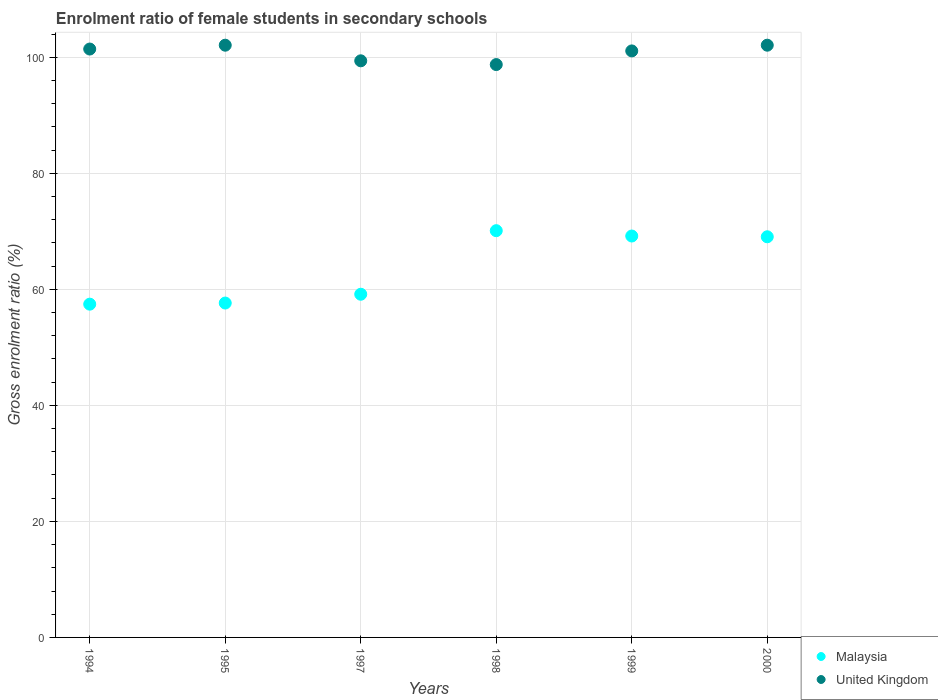What is the enrolment ratio of female students in secondary schools in United Kingdom in 1999?
Offer a terse response. 101.09. Across all years, what is the maximum enrolment ratio of female students in secondary schools in United Kingdom?
Make the answer very short. 102.07. Across all years, what is the minimum enrolment ratio of female students in secondary schools in Malaysia?
Provide a short and direct response. 57.44. In which year was the enrolment ratio of female students in secondary schools in United Kingdom maximum?
Provide a short and direct response. 2000. What is the total enrolment ratio of female students in secondary schools in United Kingdom in the graph?
Give a very brief answer. 604.77. What is the difference between the enrolment ratio of female students in secondary schools in Malaysia in 1998 and that in 1999?
Keep it short and to the point. 0.92. What is the difference between the enrolment ratio of female students in secondary schools in United Kingdom in 1994 and the enrolment ratio of female students in secondary schools in Malaysia in 1997?
Your answer should be very brief. 42.26. What is the average enrolment ratio of female students in secondary schools in Malaysia per year?
Offer a terse response. 63.76. In the year 2000, what is the difference between the enrolment ratio of female students in secondary schools in United Kingdom and enrolment ratio of female students in secondary schools in Malaysia?
Keep it short and to the point. 33.02. What is the ratio of the enrolment ratio of female students in secondary schools in United Kingdom in 1997 to that in 1998?
Provide a succinct answer. 1.01. Is the enrolment ratio of female students in secondary schools in Malaysia in 1997 less than that in 2000?
Your answer should be compact. Yes. What is the difference between the highest and the second highest enrolment ratio of female students in secondary schools in Malaysia?
Make the answer very short. 0.92. What is the difference between the highest and the lowest enrolment ratio of female students in secondary schools in United Kingdom?
Provide a succinct answer. 3.34. In how many years, is the enrolment ratio of female students in secondary schools in Malaysia greater than the average enrolment ratio of female students in secondary schools in Malaysia taken over all years?
Offer a terse response. 3. Is the sum of the enrolment ratio of female students in secondary schools in Malaysia in 1994 and 1997 greater than the maximum enrolment ratio of female students in secondary schools in United Kingdom across all years?
Your answer should be very brief. Yes. Does the enrolment ratio of female students in secondary schools in Malaysia monotonically increase over the years?
Your answer should be compact. No. Is the enrolment ratio of female students in secondary schools in United Kingdom strictly greater than the enrolment ratio of female students in secondary schools in Malaysia over the years?
Give a very brief answer. Yes. Is the enrolment ratio of female students in secondary schools in Malaysia strictly less than the enrolment ratio of female students in secondary schools in United Kingdom over the years?
Your response must be concise. Yes. How many dotlines are there?
Offer a very short reply. 2. What is the difference between two consecutive major ticks on the Y-axis?
Keep it short and to the point. 20. Does the graph contain any zero values?
Keep it short and to the point. No. Does the graph contain grids?
Your answer should be compact. Yes. Where does the legend appear in the graph?
Your answer should be compact. Bottom right. How many legend labels are there?
Keep it short and to the point. 2. How are the legend labels stacked?
Keep it short and to the point. Vertical. What is the title of the graph?
Ensure brevity in your answer.  Enrolment ratio of female students in secondary schools. What is the label or title of the X-axis?
Your answer should be very brief. Years. What is the label or title of the Y-axis?
Your response must be concise. Gross enrolment ratio (%). What is the Gross enrolment ratio (%) in Malaysia in 1994?
Keep it short and to the point. 57.44. What is the Gross enrolment ratio (%) in United Kingdom in 1994?
Offer a very short reply. 101.41. What is the Gross enrolment ratio (%) in Malaysia in 1995?
Your answer should be compact. 57.63. What is the Gross enrolment ratio (%) in United Kingdom in 1995?
Give a very brief answer. 102.07. What is the Gross enrolment ratio (%) in Malaysia in 1997?
Your response must be concise. 59.15. What is the Gross enrolment ratio (%) of United Kingdom in 1997?
Offer a very short reply. 99.38. What is the Gross enrolment ratio (%) of Malaysia in 1998?
Your answer should be compact. 70.1. What is the Gross enrolment ratio (%) in United Kingdom in 1998?
Offer a very short reply. 98.74. What is the Gross enrolment ratio (%) in Malaysia in 1999?
Offer a terse response. 69.19. What is the Gross enrolment ratio (%) in United Kingdom in 1999?
Provide a short and direct response. 101.09. What is the Gross enrolment ratio (%) in Malaysia in 2000?
Keep it short and to the point. 69.05. What is the Gross enrolment ratio (%) of United Kingdom in 2000?
Ensure brevity in your answer.  102.07. Across all years, what is the maximum Gross enrolment ratio (%) of Malaysia?
Offer a very short reply. 70.1. Across all years, what is the maximum Gross enrolment ratio (%) in United Kingdom?
Your response must be concise. 102.07. Across all years, what is the minimum Gross enrolment ratio (%) of Malaysia?
Give a very brief answer. 57.44. Across all years, what is the minimum Gross enrolment ratio (%) of United Kingdom?
Your response must be concise. 98.74. What is the total Gross enrolment ratio (%) in Malaysia in the graph?
Give a very brief answer. 382.57. What is the total Gross enrolment ratio (%) in United Kingdom in the graph?
Give a very brief answer. 604.77. What is the difference between the Gross enrolment ratio (%) of Malaysia in 1994 and that in 1995?
Your answer should be very brief. -0.19. What is the difference between the Gross enrolment ratio (%) of United Kingdom in 1994 and that in 1995?
Your answer should be very brief. -0.66. What is the difference between the Gross enrolment ratio (%) of Malaysia in 1994 and that in 1997?
Give a very brief answer. -1.71. What is the difference between the Gross enrolment ratio (%) of United Kingdom in 1994 and that in 1997?
Offer a terse response. 2.03. What is the difference between the Gross enrolment ratio (%) in Malaysia in 1994 and that in 1998?
Give a very brief answer. -12.67. What is the difference between the Gross enrolment ratio (%) in United Kingdom in 1994 and that in 1998?
Your answer should be compact. 2.68. What is the difference between the Gross enrolment ratio (%) of Malaysia in 1994 and that in 1999?
Your response must be concise. -11.75. What is the difference between the Gross enrolment ratio (%) in United Kingdom in 1994 and that in 1999?
Your answer should be compact. 0.32. What is the difference between the Gross enrolment ratio (%) of Malaysia in 1994 and that in 2000?
Your answer should be very brief. -11.61. What is the difference between the Gross enrolment ratio (%) in United Kingdom in 1994 and that in 2000?
Provide a short and direct response. -0.66. What is the difference between the Gross enrolment ratio (%) in Malaysia in 1995 and that in 1997?
Provide a short and direct response. -1.52. What is the difference between the Gross enrolment ratio (%) of United Kingdom in 1995 and that in 1997?
Keep it short and to the point. 2.69. What is the difference between the Gross enrolment ratio (%) of Malaysia in 1995 and that in 1998?
Ensure brevity in your answer.  -12.47. What is the difference between the Gross enrolment ratio (%) in United Kingdom in 1995 and that in 1998?
Provide a succinct answer. 3.34. What is the difference between the Gross enrolment ratio (%) in Malaysia in 1995 and that in 1999?
Keep it short and to the point. -11.55. What is the difference between the Gross enrolment ratio (%) of Malaysia in 1995 and that in 2000?
Your response must be concise. -11.42. What is the difference between the Gross enrolment ratio (%) of United Kingdom in 1995 and that in 2000?
Provide a succinct answer. -0. What is the difference between the Gross enrolment ratio (%) in Malaysia in 1997 and that in 1998?
Give a very brief answer. -10.95. What is the difference between the Gross enrolment ratio (%) in United Kingdom in 1997 and that in 1998?
Offer a very short reply. 0.65. What is the difference between the Gross enrolment ratio (%) in Malaysia in 1997 and that in 1999?
Provide a succinct answer. -10.04. What is the difference between the Gross enrolment ratio (%) of United Kingdom in 1997 and that in 1999?
Keep it short and to the point. -1.7. What is the difference between the Gross enrolment ratio (%) in Malaysia in 1997 and that in 2000?
Keep it short and to the point. -9.9. What is the difference between the Gross enrolment ratio (%) of United Kingdom in 1997 and that in 2000?
Keep it short and to the point. -2.69. What is the difference between the Gross enrolment ratio (%) in Malaysia in 1998 and that in 1999?
Provide a succinct answer. 0.92. What is the difference between the Gross enrolment ratio (%) of United Kingdom in 1998 and that in 1999?
Your response must be concise. -2.35. What is the difference between the Gross enrolment ratio (%) in Malaysia in 1998 and that in 2000?
Offer a very short reply. 1.05. What is the difference between the Gross enrolment ratio (%) of United Kingdom in 1998 and that in 2000?
Your answer should be very brief. -3.34. What is the difference between the Gross enrolment ratio (%) in Malaysia in 1999 and that in 2000?
Keep it short and to the point. 0.13. What is the difference between the Gross enrolment ratio (%) in United Kingdom in 1999 and that in 2000?
Offer a terse response. -0.99. What is the difference between the Gross enrolment ratio (%) in Malaysia in 1994 and the Gross enrolment ratio (%) in United Kingdom in 1995?
Give a very brief answer. -44.63. What is the difference between the Gross enrolment ratio (%) of Malaysia in 1994 and the Gross enrolment ratio (%) of United Kingdom in 1997?
Provide a short and direct response. -41.94. What is the difference between the Gross enrolment ratio (%) of Malaysia in 1994 and the Gross enrolment ratio (%) of United Kingdom in 1998?
Make the answer very short. -41.3. What is the difference between the Gross enrolment ratio (%) of Malaysia in 1994 and the Gross enrolment ratio (%) of United Kingdom in 1999?
Offer a very short reply. -43.65. What is the difference between the Gross enrolment ratio (%) of Malaysia in 1994 and the Gross enrolment ratio (%) of United Kingdom in 2000?
Make the answer very short. -44.63. What is the difference between the Gross enrolment ratio (%) in Malaysia in 1995 and the Gross enrolment ratio (%) in United Kingdom in 1997?
Your answer should be very brief. -41.75. What is the difference between the Gross enrolment ratio (%) of Malaysia in 1995 and the Gross enrolment ratio (%) of United Kingdom in 1998?
Make the answer very short. -41.1. What is the difference between the Gross enrolment ratio (%) in Malaysia in 1995 and the Gross enrolment ratio (%) in United Kingdom in 1999?
Make the answer very short. -43.45. What is the difference between the Gross enrolment ratio (%) in Malaysia in 1995 and the Gross enrolment ratio (%) in United Kingdom in 2000?
Provide a succinct answer. -44.44. What is the difference between the Gross enrolment ratio (%) in Malaysia in 1997 and the Gross enrolment ratio (%) in United Kingdom in 1998?
Provide a short and direct response. -39.59. What is the difference between the Gross enrolment ratio (%) of Malaysia in 1997 and the Gross enrolment ratio (%) of United Kingdom in 1999?
Your answer should be very brief. -41.94. What is the difference between the Gross enrolment ratio (%) in Malaysia in 1997 and the Gross enrolment ratio (%) in United Kingdom in 2000?
Give a very brief answer. -42.92. What is the difference between the Gross enrolment ratio (%) of Malaysia in 1998 and the Gross enrolment ratio (%) of United Kingdom in 1999?
Give a very brief answer. -30.98. What is the difference between the Gross enrolment ratio (%) in Malaysia in 1998 and the Gross enrolment ratio (%) in United Kingdom in 2000?
Offer a very short reply. -31.97. What is the difference between the Gross enrolment ratio (%) of Malaysia in 1999 and the Gross enrolment ratio (%) of United Kingdom in 2000?
Offer a very short reply. -32.89. What is the average Gross enrolment ratio (%) of Malaysia per year?
Give a very brief answer. 63.76. What is the average Gross enrolment ratio (%) in United Kingdom per year?
Make the answer very short. 100.79. In the year 1994, what is the difference between the Gross enrolment ratio (%) in Malaysia and Gross enrolment ratio (%) in United Kingdom?
Your response must be concise. -43.97. In the year 1995, what is the difference between the Gross enrolment ratio (%) in Malaysia and Gross enrolment ratio (%) in United Kingdom?
Your response must be concise. -44.44. In the year 1997, what is the difference between the Gross enrolment ratio (%) in Malaysia and Gross enrolment ratio (%) in United Kingdom?
Your answer should be very brief. -40.23. In the year 1998, what is the difference between the Gross enrolment ratio (%) in Malaysia and Gross enrolment ratio (%) in United Kingdom?
Keep it short and to the point. -28.63. In the year 1999, what is the difference between the Gross enrolment ratio (%) of Malaysia and Gross enrolment ratio (%) of United Kingdom?
Provide a succinct answer. -31.9. In the year 2000, what is the difference between the Gross enrolment ratio (%) in Malaysia and Gross enrolment ratio (%) in United Kingdom?
Offer a terse response. -33.02. What is the ratio of the Gross enrolment ratio (%) in Malaysia in 1994 to that in 1997?
Make the answer very short. 0.97. What is the ratio of the Gross enrolment ratio (%) in United Kingdom in 1994 to that in 1997?
Provide a succinct answer. 1.02. What is the ratio of the Gross enrolment ratio (%) in Malaysia in 1994 to that in 1998?
Provide a short and direct response. 0.82. What is the ratio of the Gross enrolment ratio (%) of United Kingdom in 1994 to that in 1998?
Your answer should be very brief. 1.03. What is the ratio of the Gross enrolment ratio (%) in Malaysia in 1994 to that in 1999?
Offer a very short reply. 0.83. What is the ratio of the Gross enrolment ratio (%) in United Kingdom in 1994 to that in 1999?
Your answer should be very brief. 1. What is the ratio of the Gross enrolment ratio (%) of Malaysia in 1994 to that in 2000?
Offer a very short reply. 0.83. What is the ratio of the Gross enrolment ratio (%) in United Kingdom in 1994 to that in 2000?
Provide a short and direct response. 0.99. What is the ratio of the Gross enrolment ratio (%) in Malaysia in 1995 to that in 1997?
Your answer should be compact. 0.97. What is the ratio of the Gross enrolment ratio (%) of United Kingdom in 1995 to that in 1997?
Your answer should be compact. 1.03. What is the ratio of the Gross enrolment ratio (%) in Malaysia in 1995 to that in 1998?
Provide a succinct answer. 0.82. What is the ratio of the Gross enrolment ratio (%) of United Kingdom in 1995 to that in 1998?
Keep it short and to the point. 1.03. What is the ratio of the Gross enrolment ratio (%) in Malaysia in 1995 to that in 1999?
Provide a short and direct response. 0.83. What is the ratio of the Gross enrolment ratio (%) of United Kingdom in 1995 to that in 1999?
Make the answer very short. 1.01. What is the ratio of the Gross enrolment ratio (%) of Malaysia in 1995 to that in 2000?
Make the answer very short. 0.83. What is the ratio of the Gross enrolment ratio (%) of Malaysia in 1997 to that in 1998?
Offer a terse response. 0.84. What is the ratio of the Gross enrolment ratio (%) in United Kingdom in 1997 to that in 1998?
Provide a succinct answer. 1.01. What is the ratio of the Gross enrolment ratio (%) of Malaysia in 1997 to that in 1999?
Offer a very short reply. 0.85. What is the ratio of the Gross enrolment ratio (%) in United Kingdom in 1997 to that in 1999?
Keep it short and to the point. 0.98. What is the ratio of the Gross enrolment ratio (%) in Malaysia in 1997 to that in 2000?
Provide a succinct answer. 0.86. What is the ratio of the Gross enrolment ratio (%) in United Kingdom in 1997 to that in 2000?
Make the answer very short. 0.97. What is the ratio of the Gross enrolment ratio (%) of Malaysia in 1998 to that in 1999?
Keep it short and to the point. 1.01. What is the ratio of the Gross enrolment ratio (%) in United Kingdom in 1998 to that in 1999?
Provide a succinct answer. 0.98. What is the ratio of the Gross enrolment ratio (%) of Malaysia in 1998 to that in 2000?
Your answer should be compact. 1.02. What is the ratio of the Gross enrolment ratio (%) in United Kingdom in 1998 to that in 2000?
Ensure brevity in your answer.  0.97. What is the ratio of the Gross enrolment ratio (%) of Malaysia in 1999 to that in 2000?
Provide a succinct answer. 1. What is the ratio of the Gross enrolment ratio (%) in United Kingdom in 1999 to that in 2000?
Provide a short and direct response. 0.99. What is the difference between the highest and the second highest Gross enrolment ratio (%) of Malaysia?
Give a very brief answer. 0.92. What is the difference between the highest and the lowest Gross enrolment ratio (%) of Malaysia?
Ensure brevity in your answer.  12.67. What is the difference between the highest and the lowest Gross enrolment ratio (%) in United Kingdom?
Give a very brief answer. 3.34. 